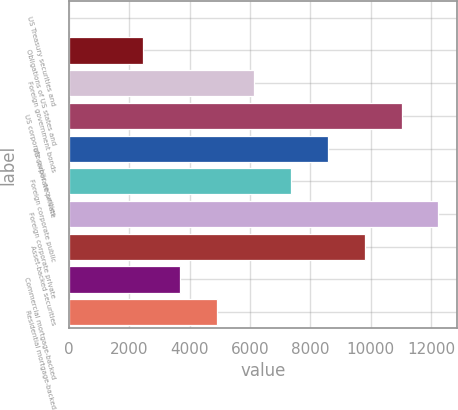Convert chart. <chart><loc_0><loc_0><loc_500><loc_500><bar_chart><fcel>US Treasury securities and<fcel>Obligations of US states and<fcel>Foreign government bonds<fcel>US corporate public securities<fcel>US corporate private<fcel>Foreign corporate public<fcel>Foreign corporate private<fcel>Asset-backed securities<fcel>Commercial mortgage-backed<fcel>Residential mortgage-backed<nl><fcel>3.64<fcel>2452.92<fcel>6126.84<fcel>11025.4<fcel>8576.12<fcel>7351.48<fcel>12250<fcel>9800.76<fcel>3677.56<fcel>4902.2<nl></chart> 